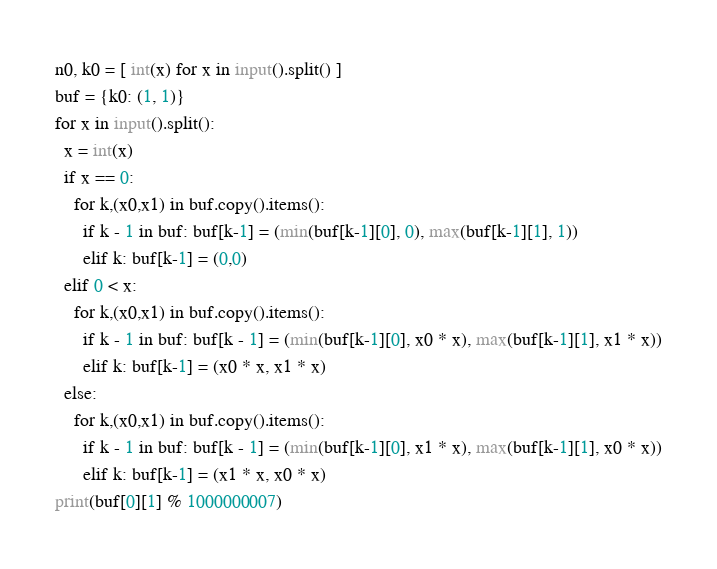Convert code to text. <code><loc_0><loc_0><loc_500><loc_500><_Python_>n0, k0 = [ int(x) for x in input().split() ]
buf = {k0: (1, 1)}
for x in input().split():
  x = int(x)
  if x == 0:
    for k,(x0,x1) in buf.copy().items():
      if k - 1 in buf: buf[k-1] = (min(buf[k-1][0], 0), max(buf[k-1][1], 1))
      elif k: buf[k-1] = (0,0)
  elif 0 < x:
    for k,(x0,x1) in buf.copy().items():
      if k - 1 in buf: buf[k - 1] = (min(buf[k-1][0], x0 * x), max(buf[k-1][1], x1 * x))
      elif k: buf[k-1] = (x0 * x, x1 * x)
  else:
    for k,(x0,x1) in buf.copy().items():
      if k - 1 in buf: buf[k - 1] = (min(buf[k-1][0], x1 * x), max(buf[k-1][1], x0 * x))
      elif k: buf[k-1] = (x1 * x, x0 * x)
print(buf[0][1] % 1000000007)</code> 